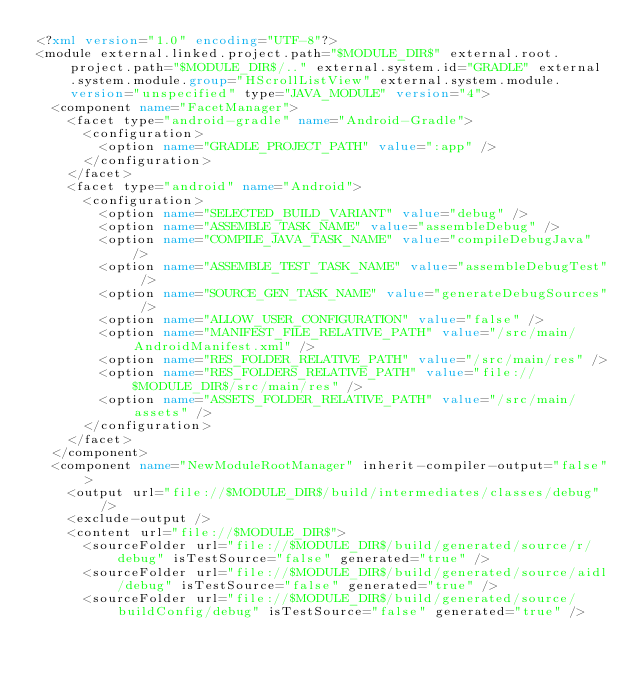Convert code to text. <code><loc_0><loc_0><loc_500><loc_500><_XML_><?xml version="1.0" encoding="UTF-8"?>
<module external.linked.project.path="$MODULE_DIR$" external.root.project.path="$MODULE_DIR$/.." external.system.id="GRADLE" external.system.module.group="HScrollListView" external.system.module.version="unspecified" type="JAVA_MODULE" version="4">
  <component name="FacetManager">
    <facet type="android-gradle" name="Android-Gradle">
      <configuration>
        <option name="GRADLE_PROJECT_PATH" value=":app" />
      </configuration>
    </facet>
    <facet type="android" name="Android">
      <configuration>
        <option name="SELECTED_BUILD_VARIANT" value="debug" />
        <option name="ASSEMBLE_TASK_NAME" value="assembleDebug" />
        <option name="COMPILE_JAVA_TASK_NAME" value="compileDebugJava" />
        <option name="ASSEMBLE_TEST_TASK_NAME" value="assembleDebugTest" />
        <option name="SOURCE_GEN_TASK_NAME" value="generateDebugSources" />
        <option name="ALLOW_USER_CONFIGURATION" value="false" />
        <option name="MANIFEST_FILE_RELATIVE_PATH" value="/src/main/AndroidManifest.xml" />
        <option name="RES_FOLDER_RELATIVE_PATH" value="/src/main/res" />
        <option name="RES_FOLDERS_RELATIVE_PATH" value="file://$MODULE_DIR$/src/main/res" />
        <option name="ASSETS_FOLDER_RELATIVE_PATH" value="/src/main/assets" />
      </configuration>
    </facet>
  </component>
  <component name="NewModuleRootManager" inherit-compiler-output="false">
    <output url="file://$MODULE_DIR$/build/intermediates/classes/debug" />
    <exclude-output />
    <content url="file://$MODULE_DIR$">
      <sourceFolder url="file://$MODULE_DIR$/build/generated/source/r/debug" isTestSource="false" generated="true" />
      <sourceFolder url="file://$MODULE_DIR$/build/generated/source/aidl/debug" isTestSource="false" generated="true" />
      <sourceFolder url="file://$MODULE_DIR$/build/generated/source/buildConfig/debug" isTestSource="false" generated="true" /></code> 